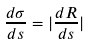Convert formula to latex. <formula><loc_0><loc_0><loc_500><loc_500>\frac { d \sigma } { d s } = | \frac { d R } { d s } |</formula> 